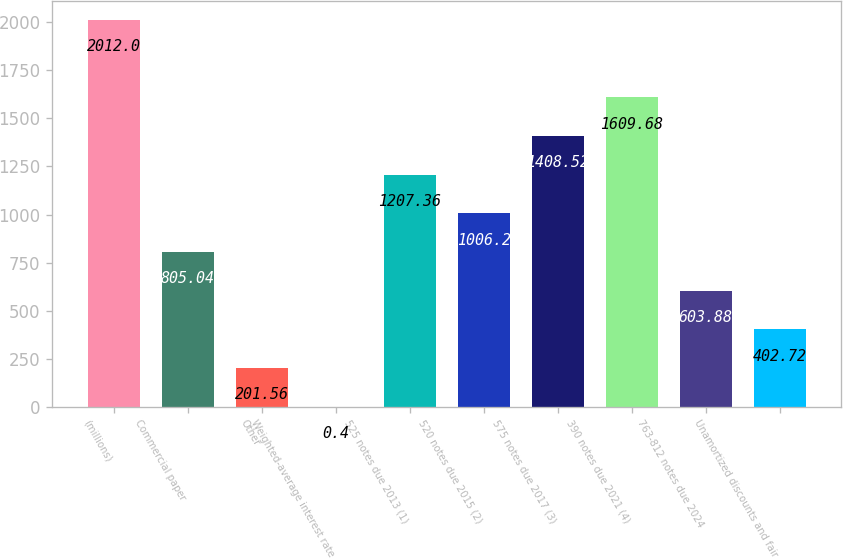Convert chart to OTSL. <chart><loc_0><loc_0><loc_500><loc_500><bar_chart><fcel>(millions)<fcel>Commercial paper<fcel>Other<fcel>Weighted-average interest rate<fcel>525 notes due 2013 (1)<fcel>520 notes due 2015 (2)<fcel>575 notes due 2017 (3)<fcel>390 notes due 2021 (4)<fcel>763-812 notes due 2024<fcel>Unamortized discounts and fair<nl><fcel>2012<fcel>805.04<fcel>201.56<fcel>0.4<fcel>1207.36<fcel>1006.2<fcel>1408.52<fcel>1609.68<fcel>603.88<fcel>402.72<nl></chart> 